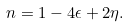<formula> <loc_0><loc_0><loc_500><loc_500>n = 1 - 4 \epsilon + 2 \eta .</formula> 